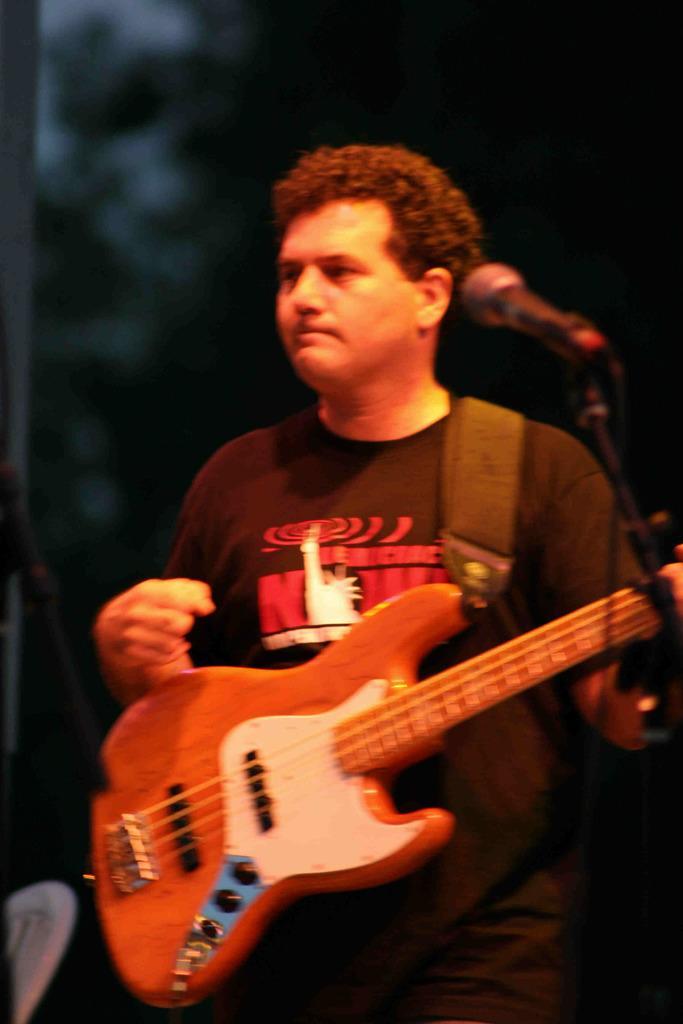Can you describe this image briefly? There is a guy stood with guitar in front of a mic. 